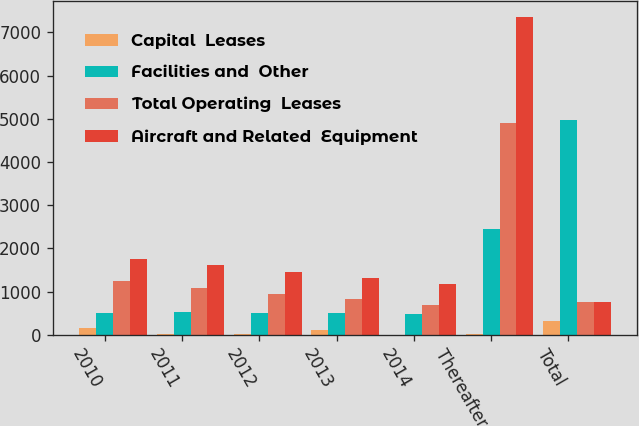Convert chart. <chart><loc_0><loc_0><loc_500><loc_500><stacked_bar_chart><ecel><fcel>2010<fcel>2011<fcel>2012<fcel>2013<fcel>2014<fcel>Thereafter<fcel>Total<nl><fcel>Capital  Leases<fcel>164<fcel>20<fcel>8<fcel>119<fcel>2<fcel>15<fcel>328<nl><fcel>Facilities and  Other<fcel>512<fcel>526<fcel>504<fcel>499<fcel>472<fcel>2458<fcel>4971<nl><fcel>Total Operating  Leases<fcel>1247<fcel>1086<fcel>947<fcel>817<fcel>694<fcel>4894<fcel>755.5<nl><fcel>Aircraft and Related  Equipment<fcel>1759<fcel>1612<fcel>1451<fcel>1316<fcel>1166<fcel>7352<fcel>755.5<nl></chart> 